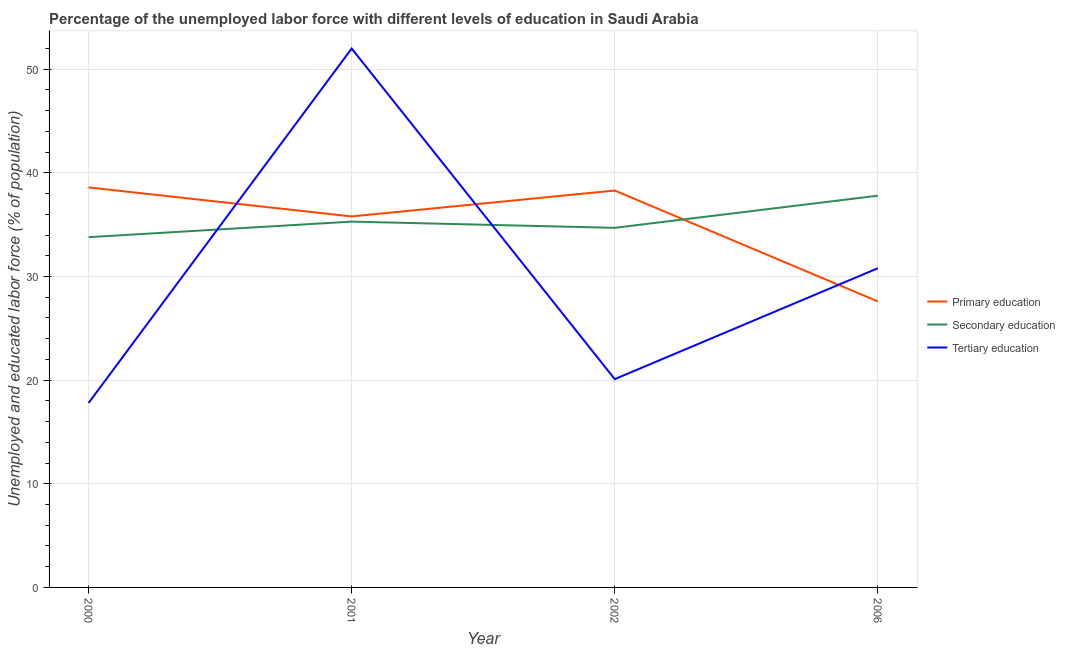Does the line corresponding to percentage of labor force who received primary education intersect with the line corresponding to percentage of labor force who received tertiary education?
Offer a terse response. Yes. Across all years, what is the maximum percentage of labor force who received tertiary education?
Offer a terse response. 52. Across all years, what is the minimum percentage of labor force who received secondary education?
Your answer should be compact. 33.8. What is the total percentage of labor force who received secondary education in the graph?
Provide a succinct answer. 141.6. What is the difference between the percentage of labor force who received primary education in 2001 and that in 2006?
Ensure brevity in your answer.  8.2. What is the average percentage of labor force who received secondary education per year?
Give a very brief answer. 35.4. In the year 2001, what is the difference between the percentage of labor force who received secondary education and percentage of labor force who received primary education?
Your response must be concise. -0.5. What is the ratio of the percentage of labor force who received tertiary education in 2000 to that in 2002?
Give a very brief answer. 0.89. Is the difference between the percentage of labor force who received tertiary education in 2000 and 2006 greater than the difference between the percentage of labor force who received secondary education in 2000 and 2006?
Provide a succinct answer. No. What is the difference between the highest and the second highest percentage of labor force who received tertiary education?
Provide a short and direct response. 21.2. Is the sum of the percentage of labor force who received secondary education in 2000 and 2002 greater than the maximum percentage of labor force who received primary education across all years?
Offer a terse response. Yes. Is it the case that in every year, the sum of the percentage of labor force who received primary education and percentage of labor force who received secondary education is greater than the percentage of labor force who received tertiary education?
Provide a succinct answer. Yes. Is the percentage of labor force who received secondary education strictly greater than the percentage of labor force who received primary education over the years?
Your answer should be very brief. No. Is the percentage of labor force who received primary education strictly less than the percentage of labor force who received secondary education over the years?
Your answer should be compact. No. How many lines are there?
Keep it short and to the point. 3. What is the difference between two consecutive major ticks on the Y-axis?
Give a very brief answer. 10. Are the values on the major ticks of Y-axis written in scientific E-notation?
Provide a short and direct response. No. Does the graph contain grids?
Offer a very short reply. Yes. Where does the legend appear in the graph?
Make the answer very short. Center right. How many legend labels are there?
Ensure brevity in your answer.  3. What is the title of the graph?
Your answer should be very brief. Percentage of the unemployed labor force with different levels of education in Saudi Arabia. Does "Maunufacturing" appear as one of the legend labels in the graph?
Offer a terse response. No. What is the label or title of the X-axis?
Make the answer very short. Year. What is the label or title of the Y-axis?
Ensure brevity in your answer.  Unemployed and educated labor force (% of population). What is the Unemployed and educated labor force (% of population) in Primary education in 2000?
Offer a terse response. 38.6. What is the Unemployed and educated labor force (% of population) of Secondary education in 2000?
Ensure brevity in your answer.  33.8. What is the Unemployed and educated labor force (% of population) in Tertiary education in 2000?
Your response must be concise. 17.8. What is the Unemployed and educated labor force (% of population) in Primary education in 2001?
Your answer should be very brief. 35.8. What is the Unemployed and educated labor force (% of population) in Secondary education in 2001?
Your answer should be very brief. 35.3. What is the Unemployed and educated labor force (% of population) in Tertiary education in 2001?
Your response must be concise. 52. What is the Unemployed and educated labor force (% of population) of Primary education in 2002?
Your response must be concise. 38.3. What is the Unemployed and educated labor force (% of population) in Secondary education in 2002?
Give a very brief answer. 34.7. What is the Unemployed and educated labor force (% of population) of Tertiary education in 2002?
Ensure brevity in your answer.  20.1. What is the Unemployed and educated labor force (% of population) in Primary education in 2006?
Make the answer very short. 27.6. What is the Unemployed and educated labor force (% of population) in Secondary education in 2006?
Your answer should be very brief. 37.8. What is the Unemployed and educated labor force (% of population) of Tertiary education in 2006?
Your answer should be compact. 30.8. Across all years, what is the maximum Unemployed and educated labor force (% of population) in Primary education?
Give a very brief answer. 38.6. Across all years, what is the maximum Unemployed and educated labor force (% of population) of Secondary education?
Provide a short and direct response. 37.8. Across all years, what is the maximum Unemployed and educated labor force (% of population) in Tertiary education?
Provide a short and direct response. 52. Across all years, what is the minimum Unemployed and educated labor force (% of population) in Primary education?
Ensure brevity in your answer.  27.6. Across all years, what is the minimum Unemployed and educated labor force (% of population) of Secondary education?
Provide a short and direct response. 33.8. Across all years, what is the minimum Unemployed and educated labor force (% of population) in Tertiary education?
Your answer should be very brief. 17.8. What is the total Unemployed and educated labor force (% of population) in Primary education in the graph?
Offer a terse response. 140.3. What is the total Unemployed and educated labor force (% of population) in Secondary education in the graph?
Your response must be concise. 141.6. What is the total Unemployed and educated labor force (% of population) of Tertiary education in the graph?
Offer a terse response. 120.7. What is the difference between the Unemployed and educated labor force (% of population) in Primary education in 2000 and that in 2001?
Your response must be concise. 2.8. What is the difference between the Unemployed and educated labor force (% of population) in Secondary education in 2000 and that in 2001?
Keep it short and to the point. -1.5. What is the difference between the Unemployed and educated labor force (% of population) of Tertiary education in 2000 and that in 2001?
Your answer should be compact. -34.2. What is the difference between the Unemployed and educated labor force (% of population) in Secondary education in 2000 and that in 2002?
Provide a short and direct response. -0.9. What is the difference between the Unemployed and educated labor force (% of population) in Primary education in 2000 and that in 2006?
Give a very brief answer. 11. What is the difference between the Unemployed and educated labor force (% of population) in Secondary education in 2000 and that in 2006?
Your answer should be compact. -4. What is the difference between the Unemployed and educated labor force (% of population) in Tertiary education in 2000 and that in 2006?
Your answer should be compact. -13. What is the difference between the Unemployed and educated labor force (% of population) in Primary education in 2001 and that in 2002?
Offer a very short reply. -2.5. What is the difference between the Unemployed and educated labor force (% of population) of Secondary education in 2001 and that in 2002?
Offer a terse response. 0.6. What is the difference between the Unemployed and educated labor force (% of population) of Tertiary education in 2001 and that in 2002?
Your answer should be compact. 31.9. What is the difference between the Unemployed and educated labor force (% of population) in Primary education in 2001 and that in 2006?
Make the answer very short. 8.2. What is the difference between the Unemployed and educated labor force (% of population) in Tertiary education in 2001 and that in 2006?
Offer a terse response. 21.2. What is the difference between the Unemployed and educated labor force (% of population) of Secondary education in 2002 and that in 2006?
Offer a terse response. -3.1. What is the difference between the Unemployed and educated labor force (% of population) in Tertiary education in 2002 and that in 2006?
Your answer should be compact. -10.7. What is the difference between the Unemployed and educated labor force (% of population) in Primary education in 2000 and the Unemployed and educated labor force (% of population) in Secondary education in 2001?
Offer a very short reply. 3.3. What is the difference between the Unemployed and educated labor force (% of population) in Primary education in 2000 and the Unemployed and educated labor force (% of population) in Tertiary education in 2001?
Offer a very short reply. -13.4. What is the difference between the Unemployed and educated labor force (% of population) of Secondary education in 2000 and the Unemployed and educated labor force (% of population) of Tertiary education in 2001?
Your answer should be compact. -18.2. What is the difference between the Unemployed and educated labor force (% of population) in Secondary education in 2000 and the Unemployed and educated labor force (% of population) in Tertiary education in 2002?
Provide a short and direct response. 13.7. What is the difference between the Unemployed and educated labor force (% of population) of Secondary education in 2000 and the Unemployed and educated labor force (% of population) of Tertiary education in 2006?
Offer a very short reply. 3. What is the difference between the Unemployed and educated labor force (% of population) in Secondary education in 2001 and the Unemployed and educated labor force (% of population) in Tertiary education in 2002?
Your answer should be compact. 15.2. What is the difference between the Unemployed and educated labor force (% of population) in Primary education in 2001 and the Unemployed and educated labor force (% of population) in Secondary education in 2006?
Keep it short and to the point. -2. What is the difference between the Unemployed and educated labor force (% of population) in Primary education in 2001 and the Unemployed and educated labor force (% of population) in Tertiary education in 2006?
Your answer should be very brief. 5. What is the difference between the Unemployed and educated labor force (% of population) of Primary education in 2002 and the Unemployed and educated labor force (% of population) of Tertiary education in 2006?
Offer a terse response. 7.5. What is the average Unemployed and educated labor force (% of population) in Primary education per year?
Ensure brevity in your answer.  35.08. What is the average Unemployed and educated labor force (% of population) in Secondary education per year?
Offer a terse response. 35.4. What is the average Unemployed and educated labor force (% of population) in Tertiary education per year?
Make the answer very short. 30.18. In the year 2000, what is the difference between the Unemployed and educated labor force (% of population) of Primary education and Unemployed and educated labor force (% of population) of Tertiary education?
Keep it short and to the point. 20.8. In the year 2000, what is the difference between the Unemployed and educated labor force (% of population) of Secondary education and Unemployed and educated labor force (% of population) of Tertiary education?
Offer a terse response. 16. In the year 2001, what is the difference between the Unemployed and educated labor force (% of population) of Primary education and Unemployed and educated labor force (% of population) of Secondary education?
Provide a short and direct response. 0.5. In the year 2001, what is the difference between the Unemployed and educated labor force (% of population) of Primary education and Unemployed and educated labor force (% of population) of Tertiary education?
Your answer should be compact. -16.2. In the year 2001, what is the difference between the Unemployed and educated labor force (% of population) of Secondary education and Unemployed and educated labor force (% of population) of Tertiary education?
Your answer should be compact. -16.7. In the year 2002, what is the difference between the Unemployed and educated labor force (% of population) in Primary education and Unemployed and educated labor force (% of population) in Secondary education?
Keep it short and to the point. 3.6. In the year 2002, what is the difference between the Unemployed and educated labor force (% of population) in Primary education and Unemployed and educated labor force (% of population) in Tertiary education?
Your response must be concise. 18.2. In the year 2002, what is the difference between the Unemployed and educated labor force (% of population) of Secondary education and Unemployed and educated labor force (% of population) of Tertiary education?
Your response must be concise. 14.6. In the year 2006, what is the difference between the Unemployed and educated labor force (% of population) in Primary education and Unemployed and educated labor force (% of population) in Secondary education?
Keep it short and to the point. -10.2. What is the ratio of the Unemployed and educated labor force (% of population) in Primary education in 2000 to that in 2001?
Give a very brief answer. 1.08. What is the ratio of the Unemployed and educated labor force (% of population) of Secondary education in 2000 to that in 2001?
Keep it short and to the point. 0.96. What is the ratio of the Unemployed and educated labor force (% of population) of Tertiary education in 2000 to that in 2001?
Offer a very short reply. 0.34. What is the ratio of the Unemployed and educated labor force (% of population) in Secondary education in 2000 to that in 2002?
Your answer should be very brief. 0.97. What is the ratio of the Unemployed and educated labor force (% of population) of Tertiary education in 2000 to that in 2002?
Make the answer very short. 0.89. What is the ratio of the Unemployed and educated labor force (% of population) in Primary education in 2000 to that in 2006?
Give a very brief answer. 1.4. What is the ratio of the Unemployed and educated labor force (% of population) in Secondary education in 2000 to that in 2006?
Offer a terse response. 0.89. What is the ratio of the Unemployed and educated labor force (% of population) in Tertiary education in 2000 to that in 2006?
Offer a very short reply. 0.58. What is the ratio of the Unemployed and educated labor force (% of population) of Primary education in 2001 to that in 2002?
Offer a very short reply. 0.93. What is the ratio of the Unemployed and educated labor force (% of population) in Secondary education in 2001 to that in 2002?
Your answer should be very brief. 1.02. What is the ratio of the Unemployed and educated labor force (% of population) in Tertiary education in 2001 to that in 2002?
Your answer should be compact. 2.59. What is the ratio of the Unemployed and educated labor force (% of population) in Primary education in 2001 to that in 2006?
Ensure brevity in your answer.  1.3. What is the ratio of the Unemployed and educated labor force (% of population) in Secondary education in 2001 to that in 2006?
Make the answer very short. 0.93. What is the ratio of the Unemployed and educated labor force (% of population) of Tertiary education in 2001 to that in 2006?
Your answer should be very brief. 1.69. What is the ratio of the Unemployed and educated labor force (% of population) in Primary education in 2002 to that in 2006?
Make the answer very short. 1.39. What is the ratio of the Unemployed and educated labor force (% of population) of Secondary education in 2002 to that in 2006?
Offer a terse response. 0.92. What is the ratio of the Unemployed and educated labor force (% of population) in Tertiary education in 2002 to that in 2006?
Provide a succinct answer. 0.65. What is the difference between the highest and the second highest Unemployed and educated labor force (% of population) in Primary education?
Make the answer very short. 0.3. What is the difference between the highest and the second highest Unemployed and educated labor force (% of population) of Tertiary education?
Your answer should be compact. 21.2. What is the difference between the highest and the lowest Unemployed and educated labor force (% of population) of Secondary education?
Provide a succinct answer. 4. What is the difference between the highest and the lowest Unemployed and educated labor force (% of population) of Tertiary education?
Your answer should be compact. 34.2. 